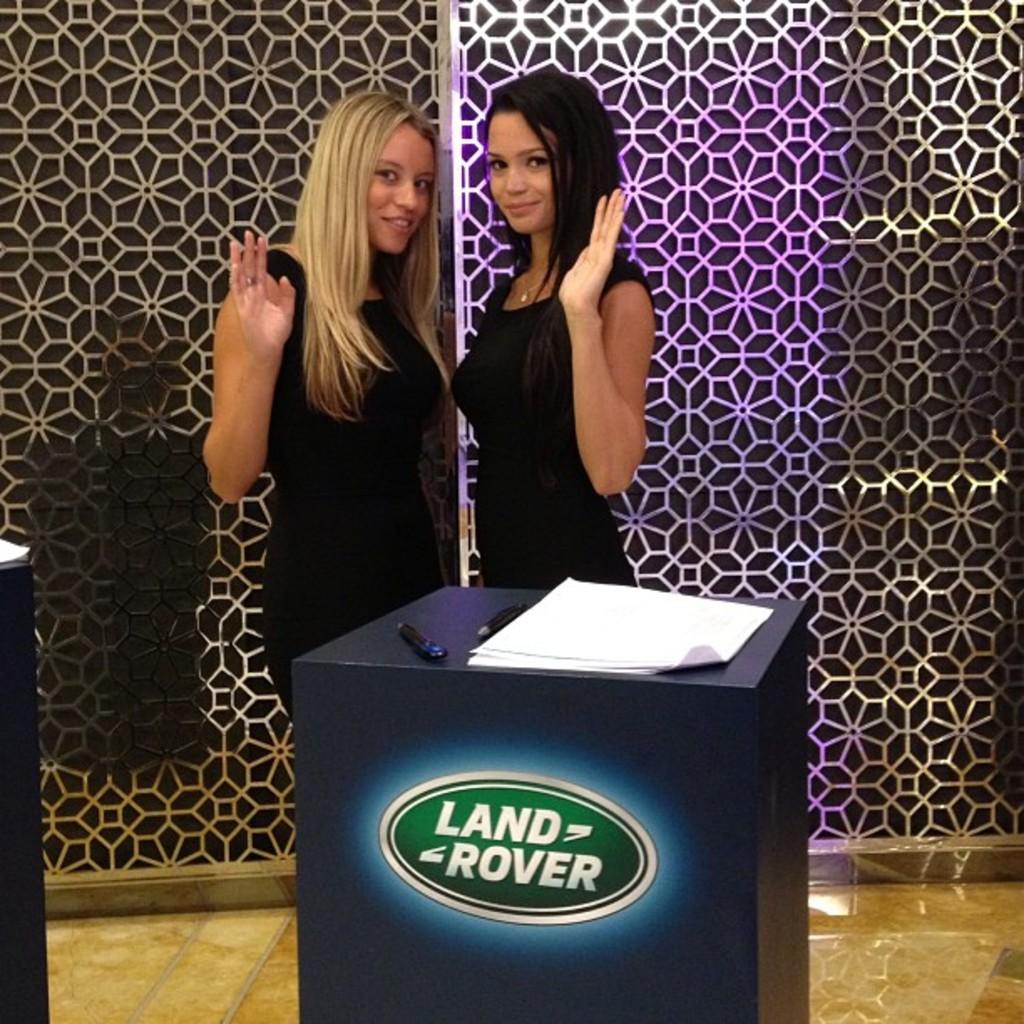How many people are in the image? There are two people standing in the image. What is the facial expression of the people in the image? The people are smiling. What is present on the table in the image? There is a table in the image with pens and papers on it. Can you see a rabbit wearing a mitten in the image? No, there is no rabbit or mitten present in the image. 